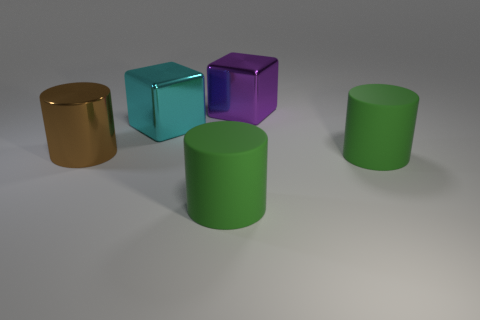Subtract all rubber cylinders. How many cylinders are left? 1 Subtract all brown cylinders. How many cylinders are left? 2 Add 4 big metallic cubes. How many objects exist? 9 Subtract all cubes. How many objects are left? 3 Subtract 1 blocks. How many blocks are left? 1 Add 3 big cyan objects. How many big cyan objects are left? 4 Add 2 brown objects. How many brown objects exist? 3 Subtract 0 blue spheres. How many objects are left? 5 Subtract all yellow cubes. Subtract all green cylinders. How many cubes are left? 2 Subtract all cyan spheres. How many blue blocks are left? 0 